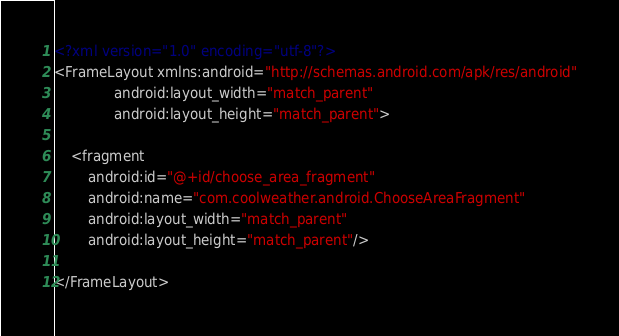Convert code to text. <code><loc_0><loc_0><loc_500><loc_500><_XML_><?xml version="1.0" encoding="utf-8"?>
<FrameLayout xmlns:android="http://schemas.android.com/apk/res/android"
              android:layout_width="match_parent"
              android:layout_height="match_parent">

    <fragment
        android:id="@+id/choose_area_fragment"
        android:name="com.coolweather.android.ChooseAreaFragment"
        android:layout_width="match_parent"
        android:layout_height="match_parent"/>

</FrameLayout>
</code> 